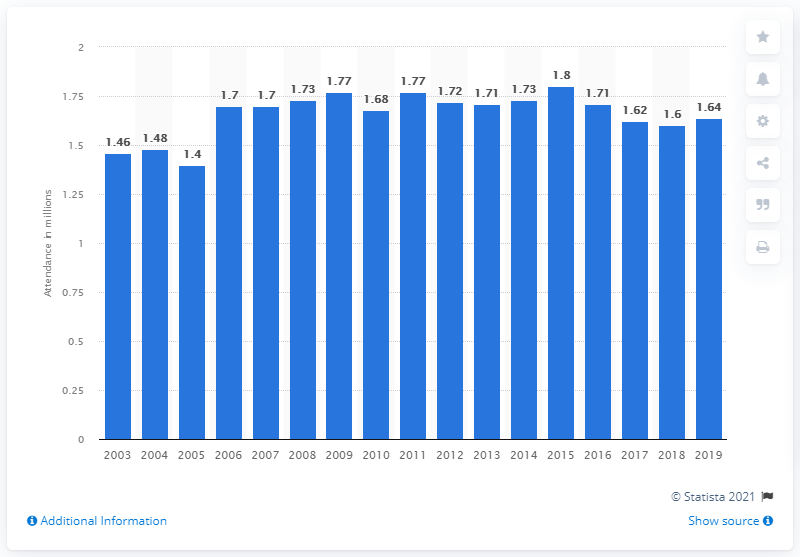Identify some key points in this picture. In the 2019 season, a total of 1.64 million spectators attended the NCAA Division I FBS bowl games. 